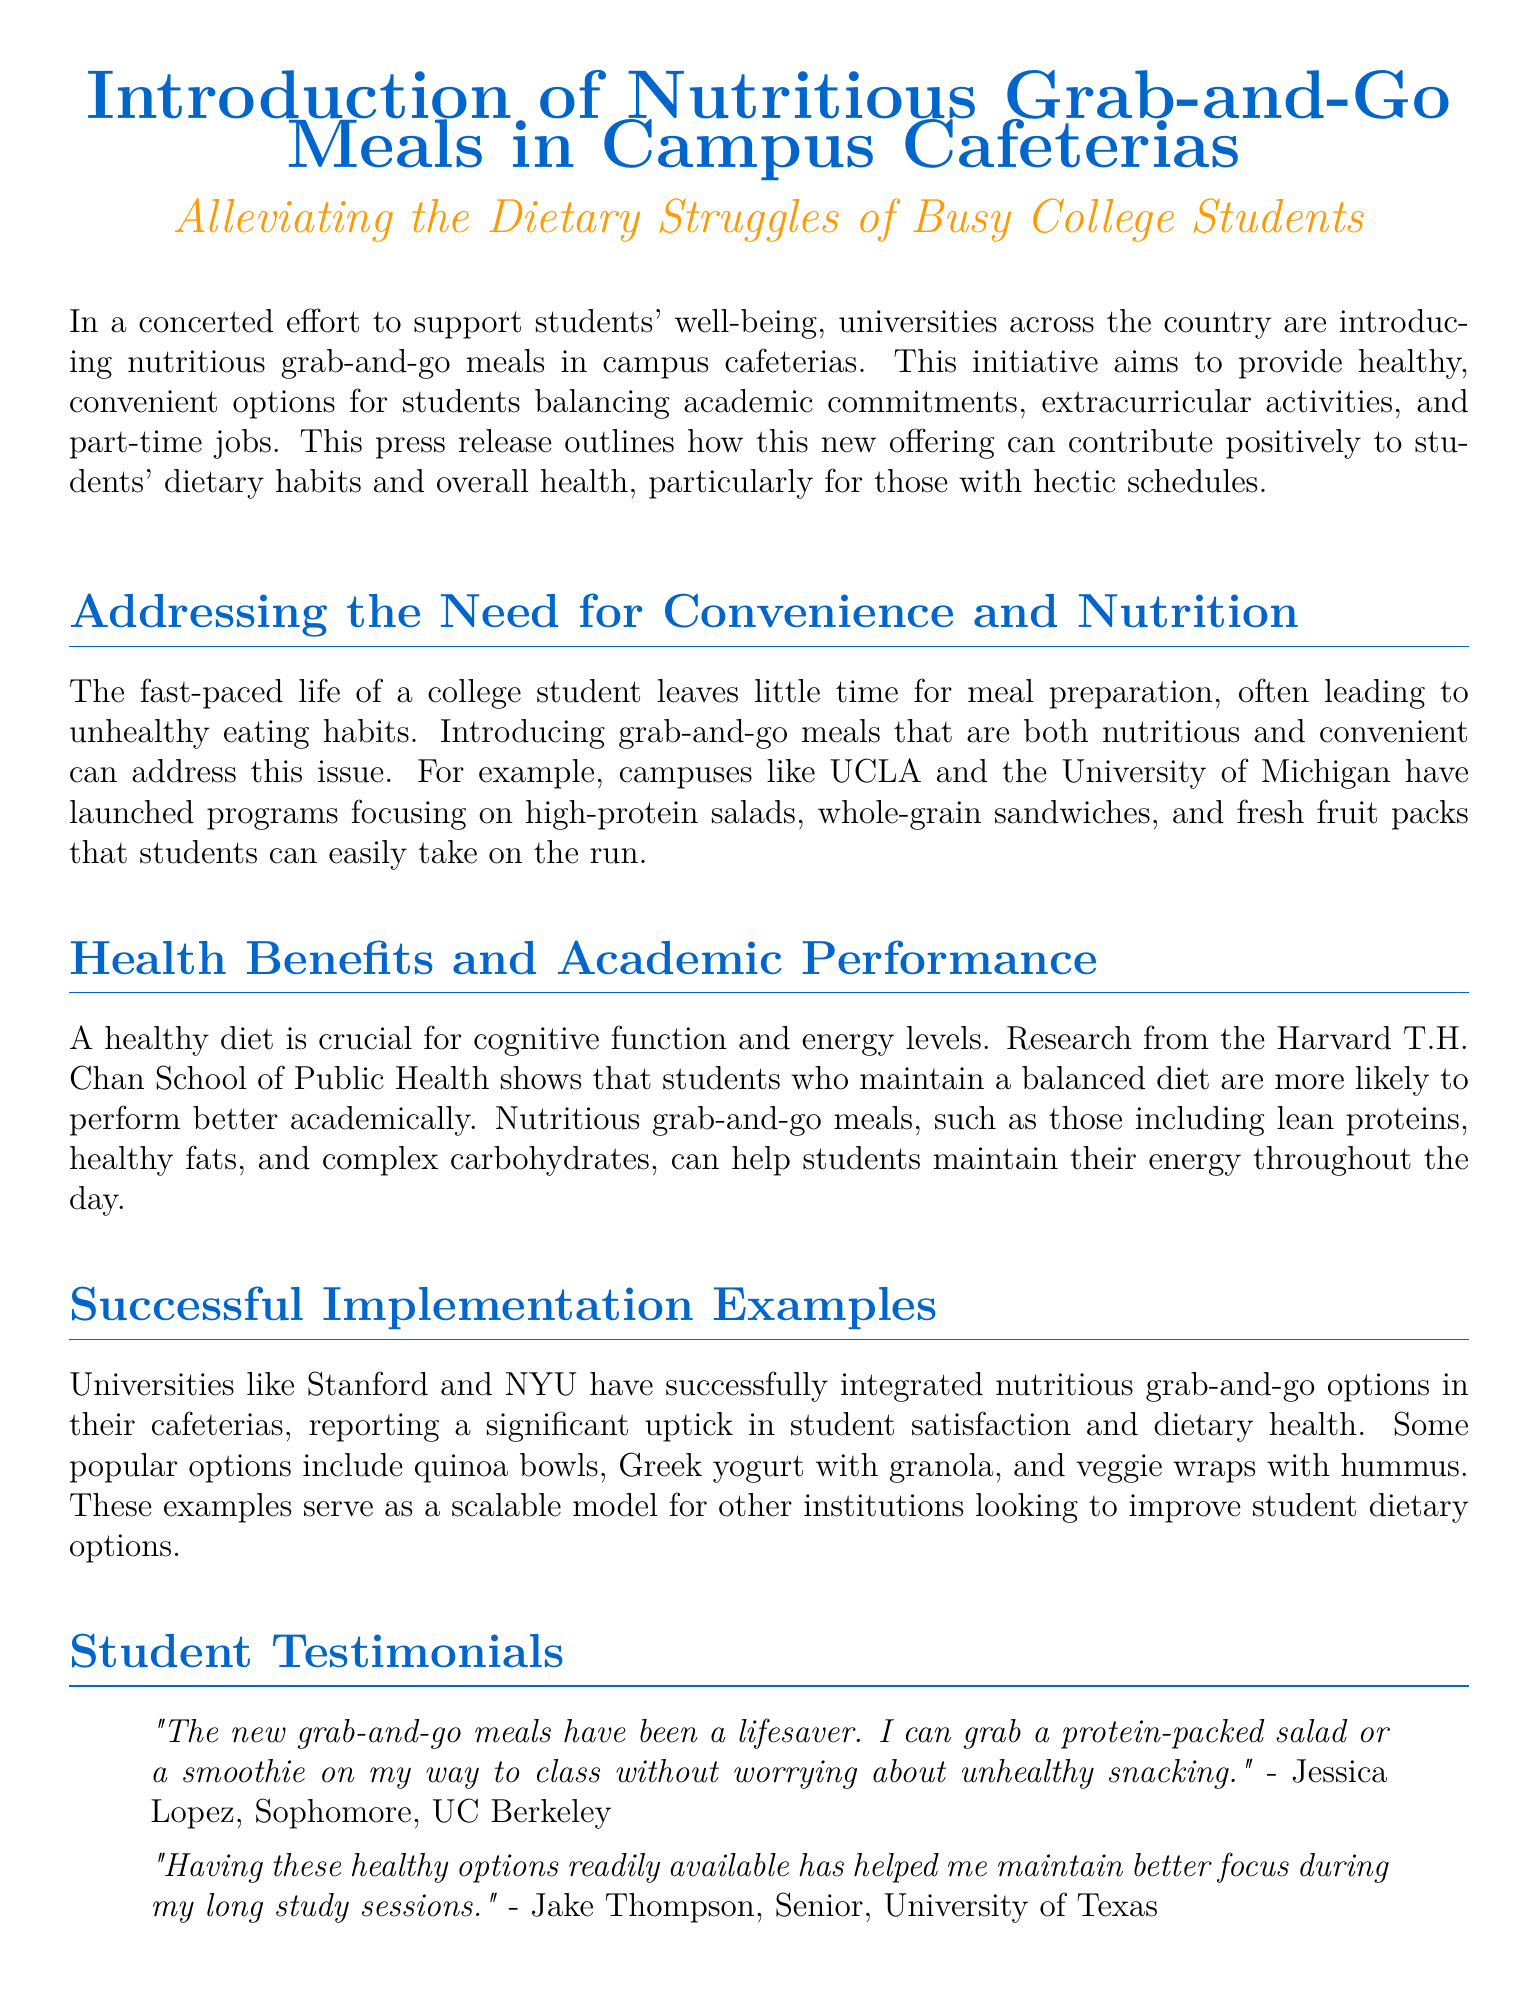what is the main focus of the initiative? The initiative aims to provide healthy, convenient options for students balancing academic commitments, extracurricular activities, and part-time jobs.
Answer: healthy, convenient options which universities are mentioned as having successful programs? The document mentions UCLA and the University of Michigan as having launched programs focusing on nutritious meals.
Answer: UCLA and University of Michigan what is one type of nutritious meal mentioned? The document provides examples of nutritious meals such as high-protein salads and whole-grain sandwiches.
Answer: high-protein salads how do nutritious meals affect academic performance? Research from the Harvard T.H. Chan School of Public Health indicates that a balanced diet is linked to better academic performance.
Answer: better academic performance who provided a testimonial about the meals? Jessica Lopez, a sophomore at UC Berkeley, gave a testimonial about the new grab-and-go meals.
Answer: Jessica Lopez what is a specific meal option mentioned in successful implementations? The document lists quinoa bowls as a popular option at universities that implemented the meals.
Answer: quinoa bowls what is the anticipated outcome of the initiative? The hope is to see a positive trend in student well-being across the country as more universities adopt the nutritious meal initiative.
Answer: positive trend in student well-being what type of feedback is important for improving meal options? Continuous feedback from students and nutrition experts is crucial for refining and expanding meal options.
Answer: feedback from students and nutrition experts how does the document classify itself? The document is structured as a press release detailing a new initiative to support student health.
Answer: press release 